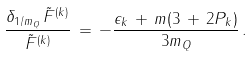<formula> <loc_0><loc_0><loc_500><loc_500>\frac { \delta _ { 1 / m _ { Q } } \, \tilde { F } ^ { ( k ) } } { \tilde { F } ^ { ( k ) } } \, = \, - \frac { \epsilon _ { k } \, + \, m ( 3 \, + \, 2 P _ { k } ) } { 3 m _ { Q } } \, .</formula> 